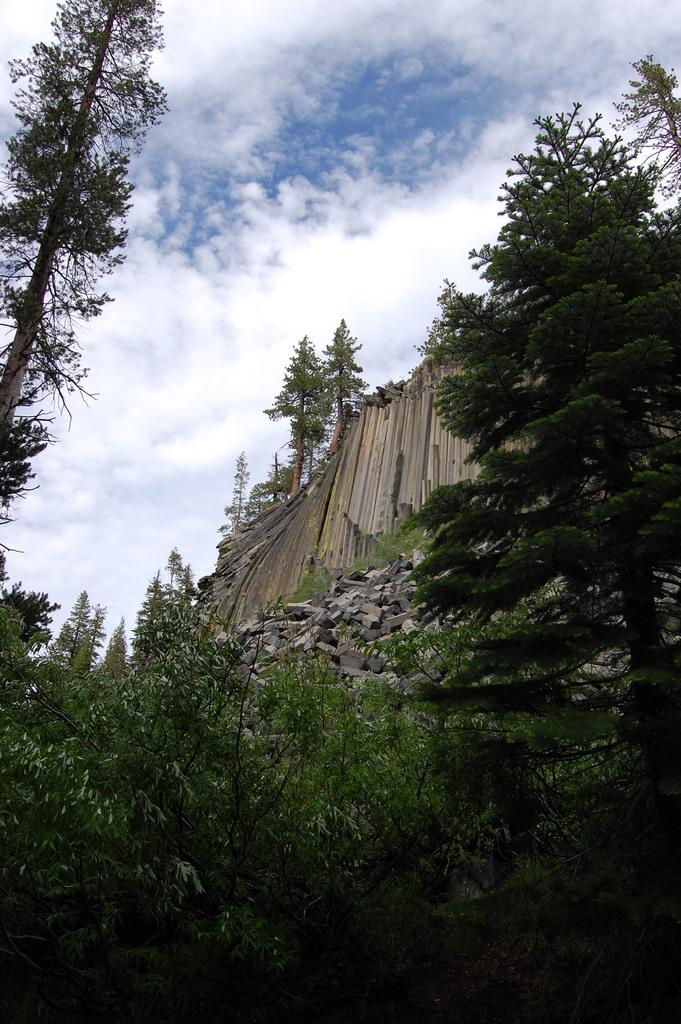What can be seen in the sky in the image? There are clouds in the sky in the image. What type of vegetation is visible in the image? There are trees visible in the image. What type of material is used for the blocks in the image? Stone blocks are present in the image. What is the material of the wall on the right side of the image? There is a wooden wall on the right side of the image. What type of glue is being used to hold the clouds together in the image? There is no glue present in the image, as clouds are natural phenomena and do not require any adhesive to maintain their shape or position. How many oranges are hanging from the wooden wall in the image? There are no oranges present in the image; it features clouds, trees, stone blocks, and a wooden wall. 